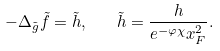Convert formula to latex. <formula><loc_0><loc_0><loc_500><loc_500>- \Delta _ { \tilde { g } } \tilde { f } = \tilde { h } , \quad \tilde { h } = \frac { h } { e ^ { - \varphi \chi } x ^ { 2 } _ { F } } .</formula> 